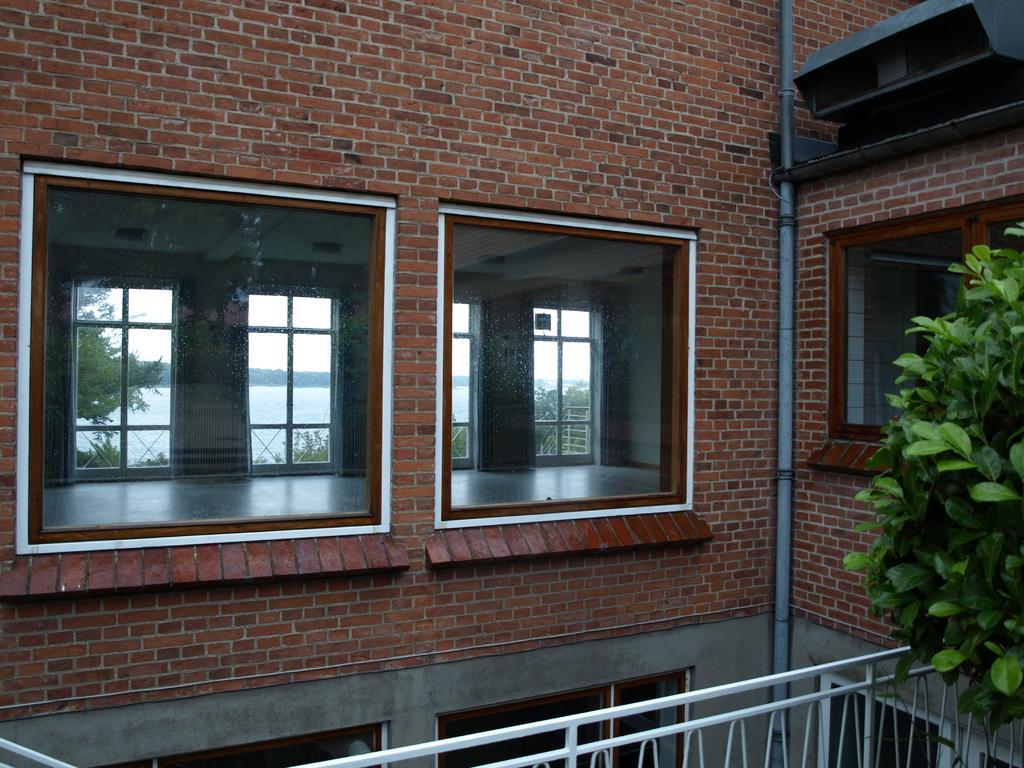Describe this image in one or two sentences. On the right side, we see a tree. Beside that, we see an iron railing. In this picture, we see a building which is made up of brown colored bricks. We see the glass windows from which we can see windows, water body and the trees. 